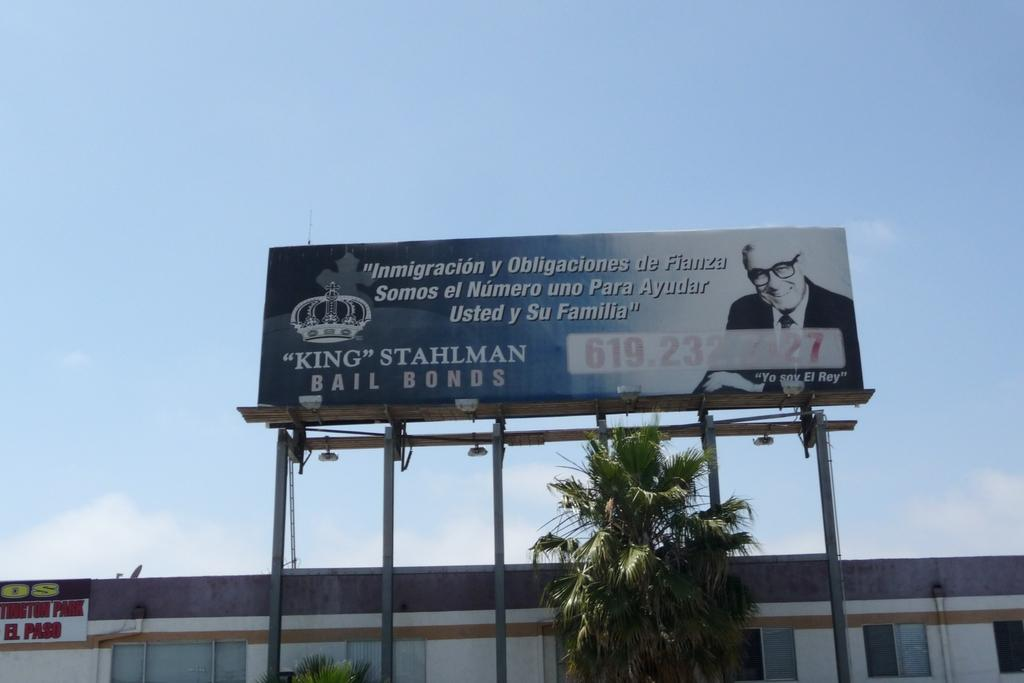<image>
Render a clear and concise summary of the photo. A bail bonds ad is above a building. 